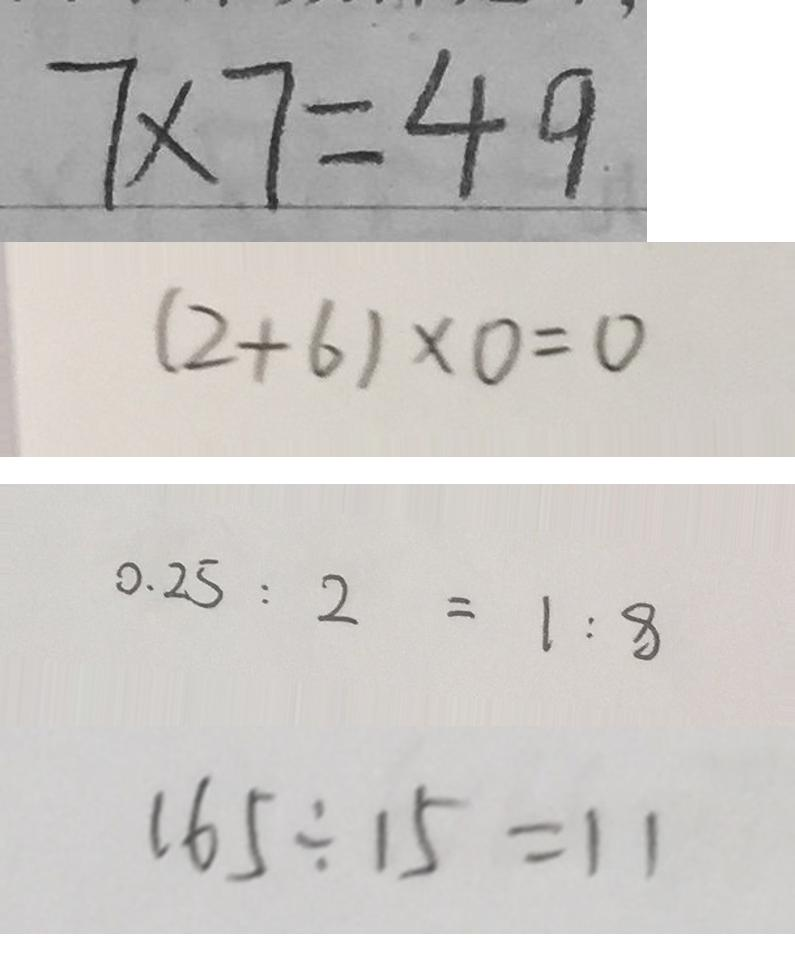Convert formula to latex. <formula><loc_0><loc_0><loc_500><loc_500>7 \times 7 = 4 9 
 ( 2 + 6 ) \times 0 = 0 
 0 . 2 5 : 2 = 1 : 8 
 1 6 5 \div 1 5 = 1 1</formula> 